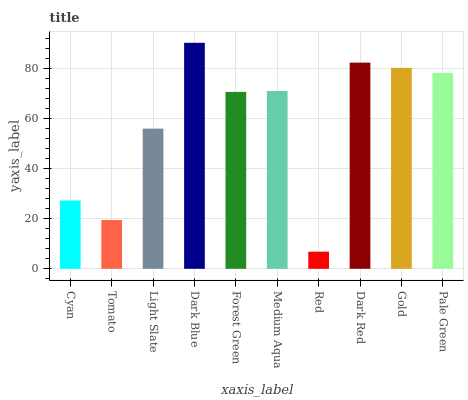Is Red the minimum?
Answer yes or no. Yes. Is Dark Blue the maximum?
Answer yes or no. Yes. Is Tomato the minimum?
Answer yes or no. No. Is Tomato the maximum?
Answer yes or no. No. Is Cyan greater than Tomato?
Answer yes or no. Yes. Is Tomato less than Cyan?
Answer yes or no. Yes. Is Tomato greater than Cyan?
Answer yes or no. No. Is Cyan less than Tomato?
Answer yes or no. No. Is Medium Aqua the high median?
Answer yes or no. Yes. Is Forest Green the low median?
Answer yes or no. Yes. Is Pale Green the high median?
Answer yes or no. No. Is Red the low median?
Answer yes or no. No. 